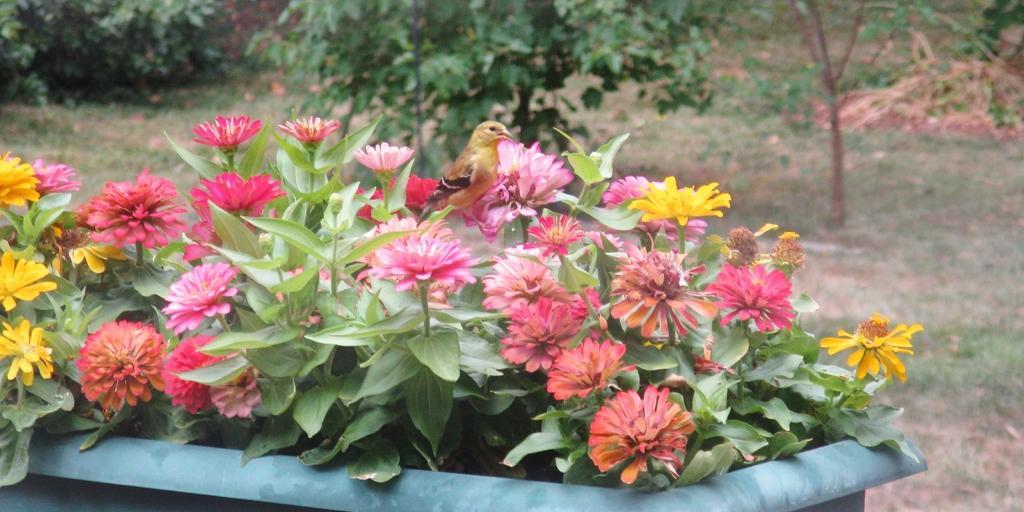Describe this image in one or two sentences. In this image there are flowers in the front inside the pot which is in the center. In the background there are trees and there's grass on the ground. 